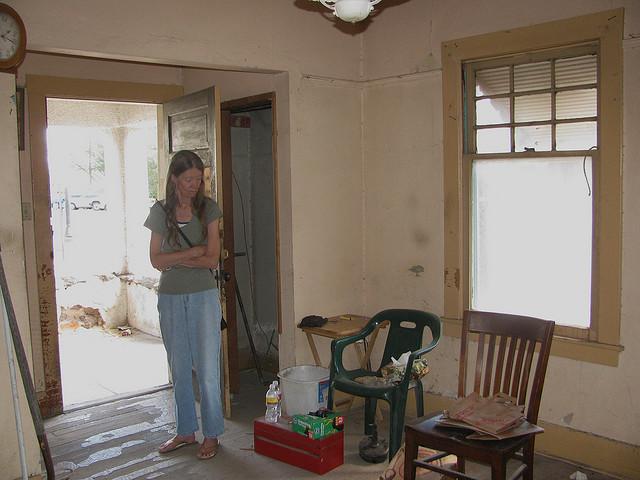How many places are there to sit?
Concise answer only. 2. How long will the remodel take to finish?
Answer briefly. Months. Is the house ready for tenants?
Concise answer only. No. Is the chair red?
Short answer required. No. Is this woman happy about cleaning?
Short answer required. No. What color box is holding the supplies?
Quick response, please. Red. 